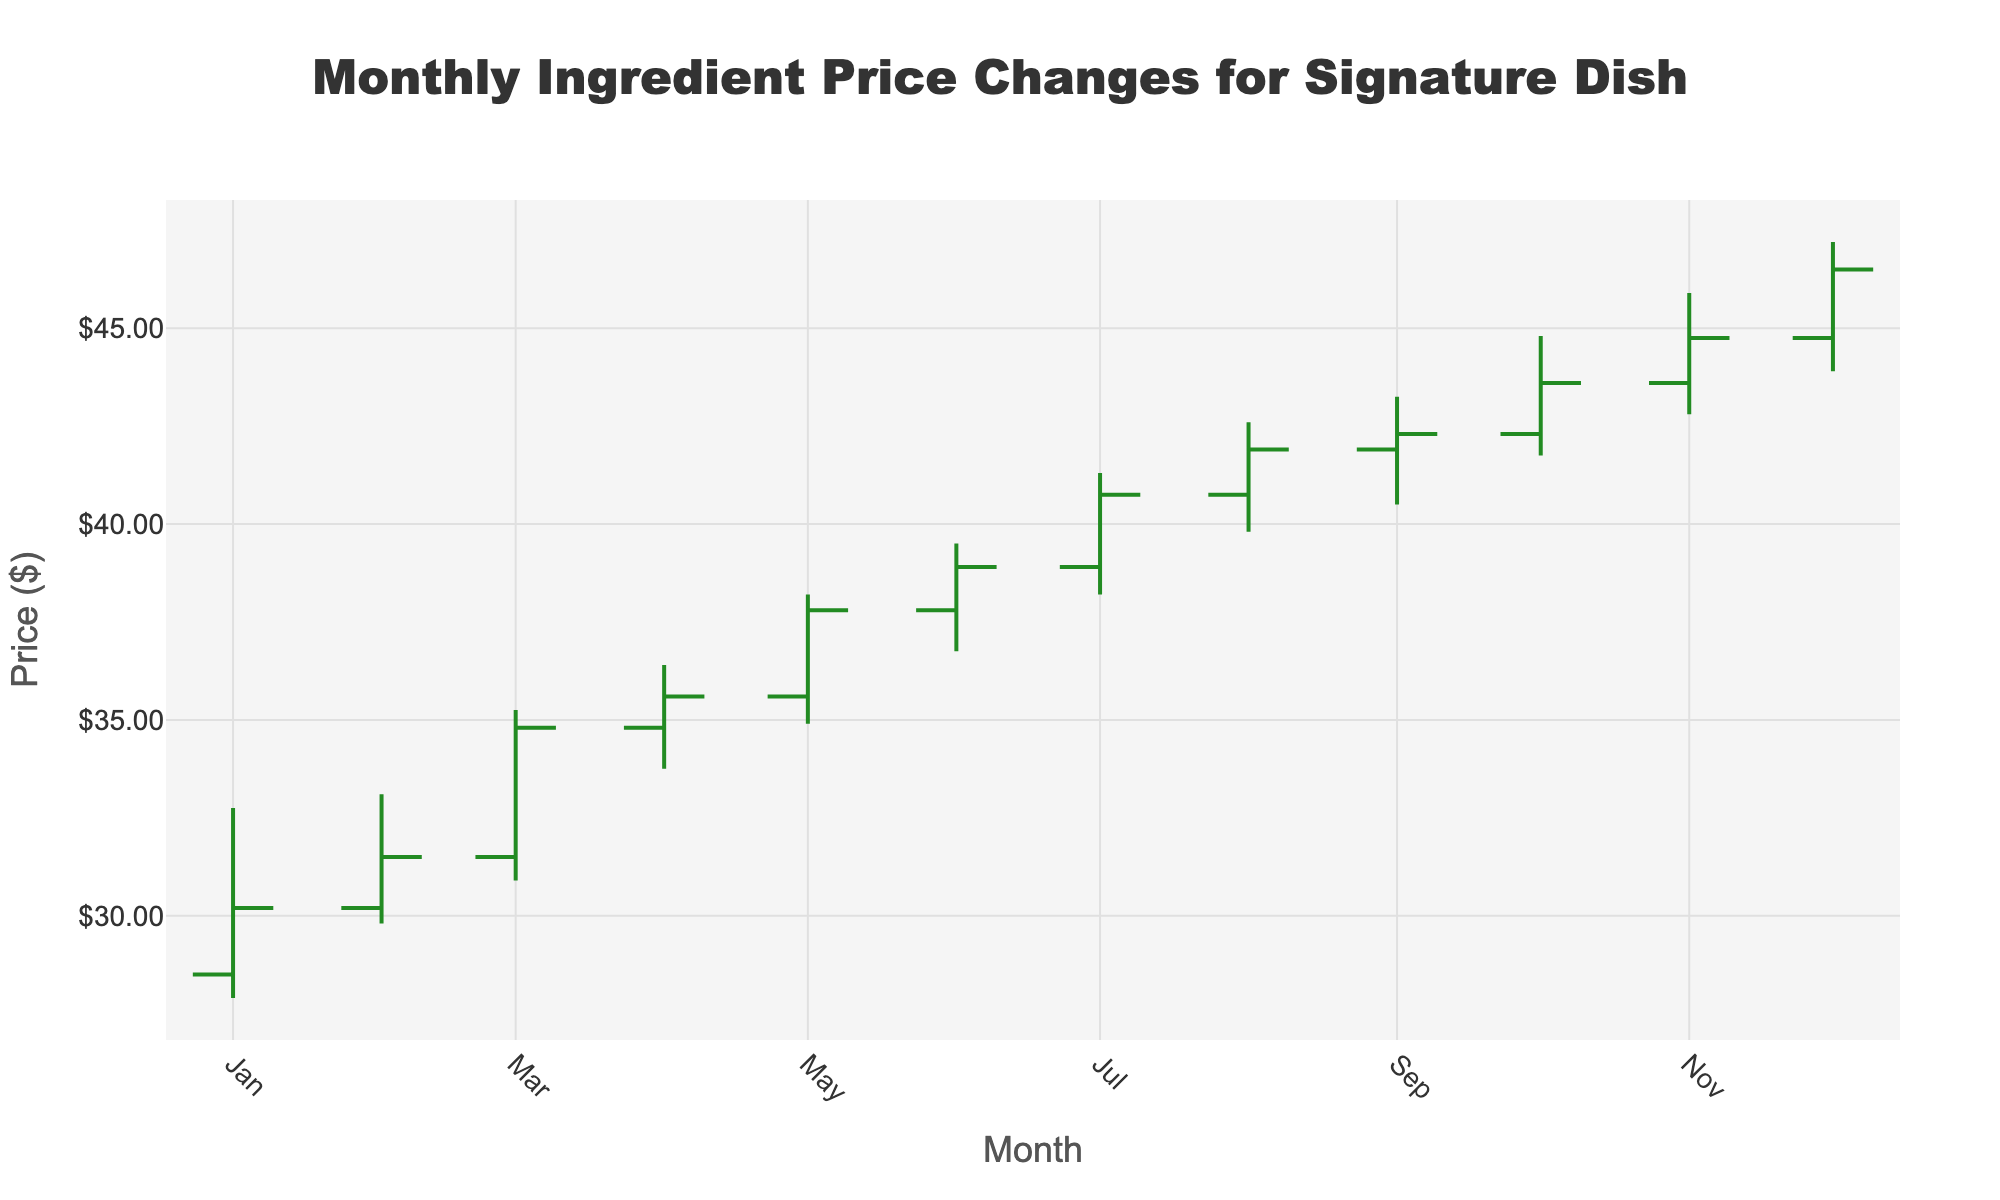Which month has the highest closing price? To find the highest closing price, we look at the "Close" column in the data. The highest value is 46.50 in December.
Answer: December What is the range of the low prices throughout the year? The range is the difference between the highest and lowest values in the "Low" column. The highest low price is 43.90 (December), and the lowest is 27.90 (January). Therefore, the range is 43.90 - 27.90 = 16.00.
Answer: 16.00 How much did the closing price increase from January to December? To find the increase, subtract the closing price in January (30.20) from the closing price in December (46.50). The increase is 46.50 - 30.20 = 16.30.
Answer: 16.30 Which month shows the greatest difference between high and low prices? To determine this, calculate the difference between the high and low prices for each month and find the maximum. The greatest difference is in December, with values 47.20 (high) - 43.90 (low) = 3.30.
Answer: December In which month did the closing price first exceed $40? We need to identify the first month when the closing price was higher than $40. This is in July, with a closing price of 40.75.
Answer: July What was the average closing price over the year? To find the average, sum all closing prices and divide by the number of months: (30.20 + 31.50 + 34.80 + 35.60 + 37.80 + 38.90 + 40.75 + 41.90 + 42.30 + 43.60 + 44.75 + 46.50) / 12 = 38.85.
Answer: 38.85 Compare the closing price trends between the first half and the second half of the year. In the first half (January to June), the closing prices are: 30.20, 31.50, 34.80, 35.60, 37.80, 38.90. In the second half (July to December), they are: 40.75, 41.90, 42.30, 43.60, 44.75, 46.50. The second half shows a clear increasing trend, while the first half shows a more moderate increase.
Answer: The second half shows a stronger increasing trend Which month had the smallest increase in closing price compared to the previous month? To find this, calculate the difference in closing prices between consecutive months and find the smallest positive change. The smallest increase occurred from April to May (37.80 - 35.60 = 0.80).
Answer: May Was there any month where the closing price was lower than the opening price? Check the "Open" and "Close" columns for each month. In every month listed, the closing price is higher than or equal to the opening price.
Answer: No What is the median closing price of the year? To find the median, list the closing prices in ascending order and find the middle value. If there are an even number of values, take the average of the two middle numbers. The sorted closing prices are: 30.20, 31.50, 34.80, 35.60, 37.80, 38.90, 40.75, 41.90, 42.30, 43.60, 44.75, 46.50. The median is the average of the 6th and 7th values, (38.90 + 40.75) / 2 = 39.83.
Answer: 39.83 